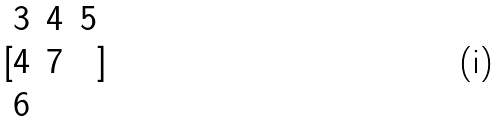<formula> <loc_0><loc_0><loc_500><loc_500>[ \begin{matrix} 3 & 4 & 5 \\ 4 & 7 \\ 6 \end{matrix} ]</formula> 